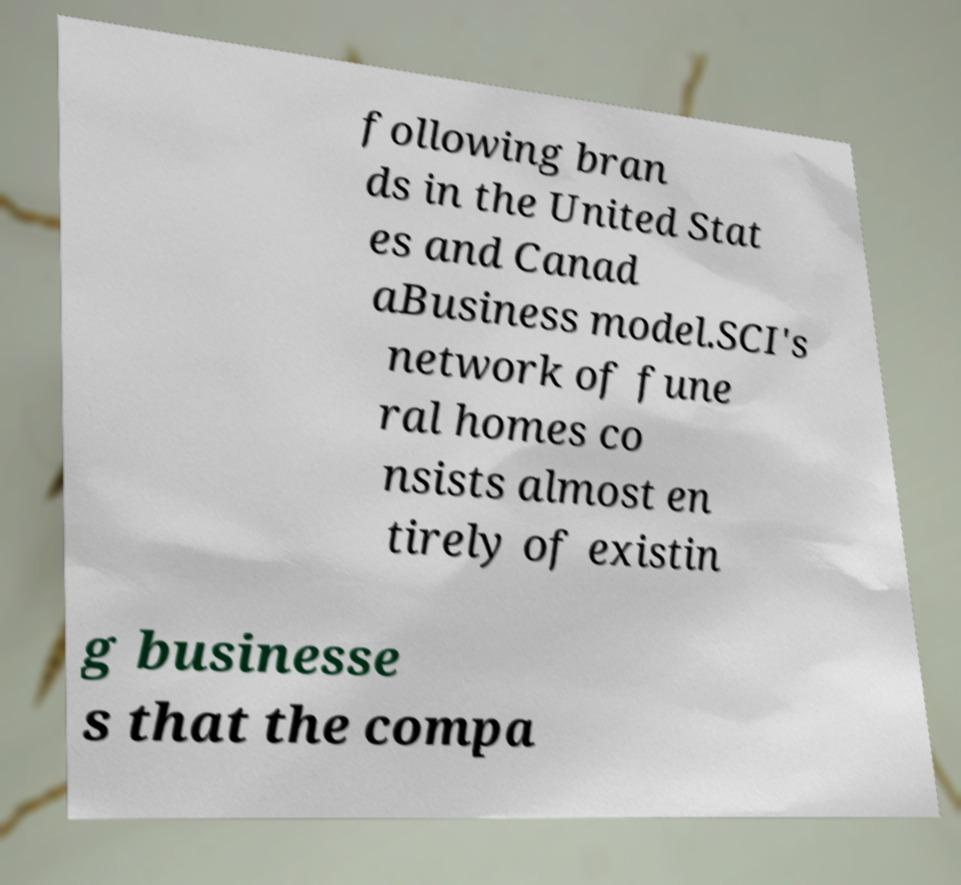What messages or text are displayed in this image? I need them in a readable, typed format. following bran ds in the United Stat es and Canad aBusiness model.SCI's network of fune ral homes co nsists almost en tirely of existin g businesse s that the compa 